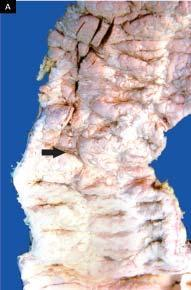what did broad base contain?
Answer the question using a single word or phrase. Necrotic tissue 